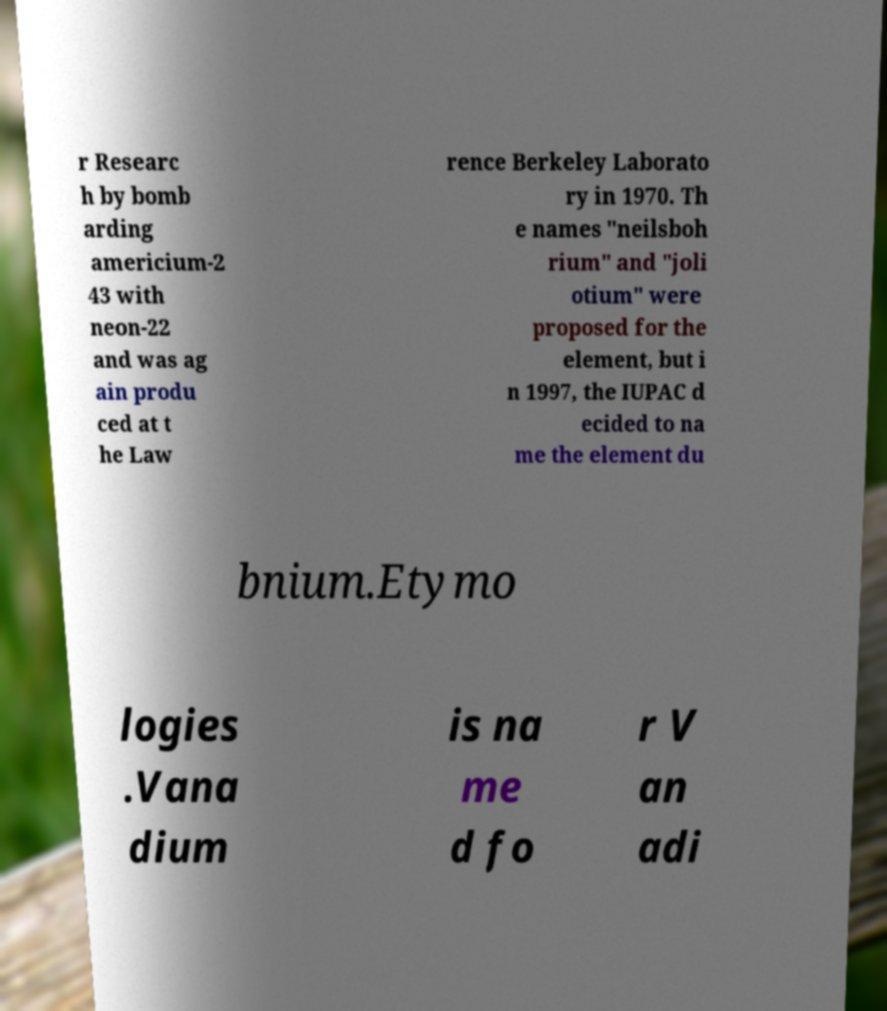Could you extract and type out the text from this image? r Researc h by bomb arding americium-2 43 with neon-22 and was ag ain produ ced at t he Law rence Berkeley Laborato ry in 1970. Th e names "neilsboh rium" and "joli otium" were proposed for the element, but i n 1997, the IUPAC d ecided to na me the element du bnium.Etymo logies .Vana dium is na me d fo r V an adi 